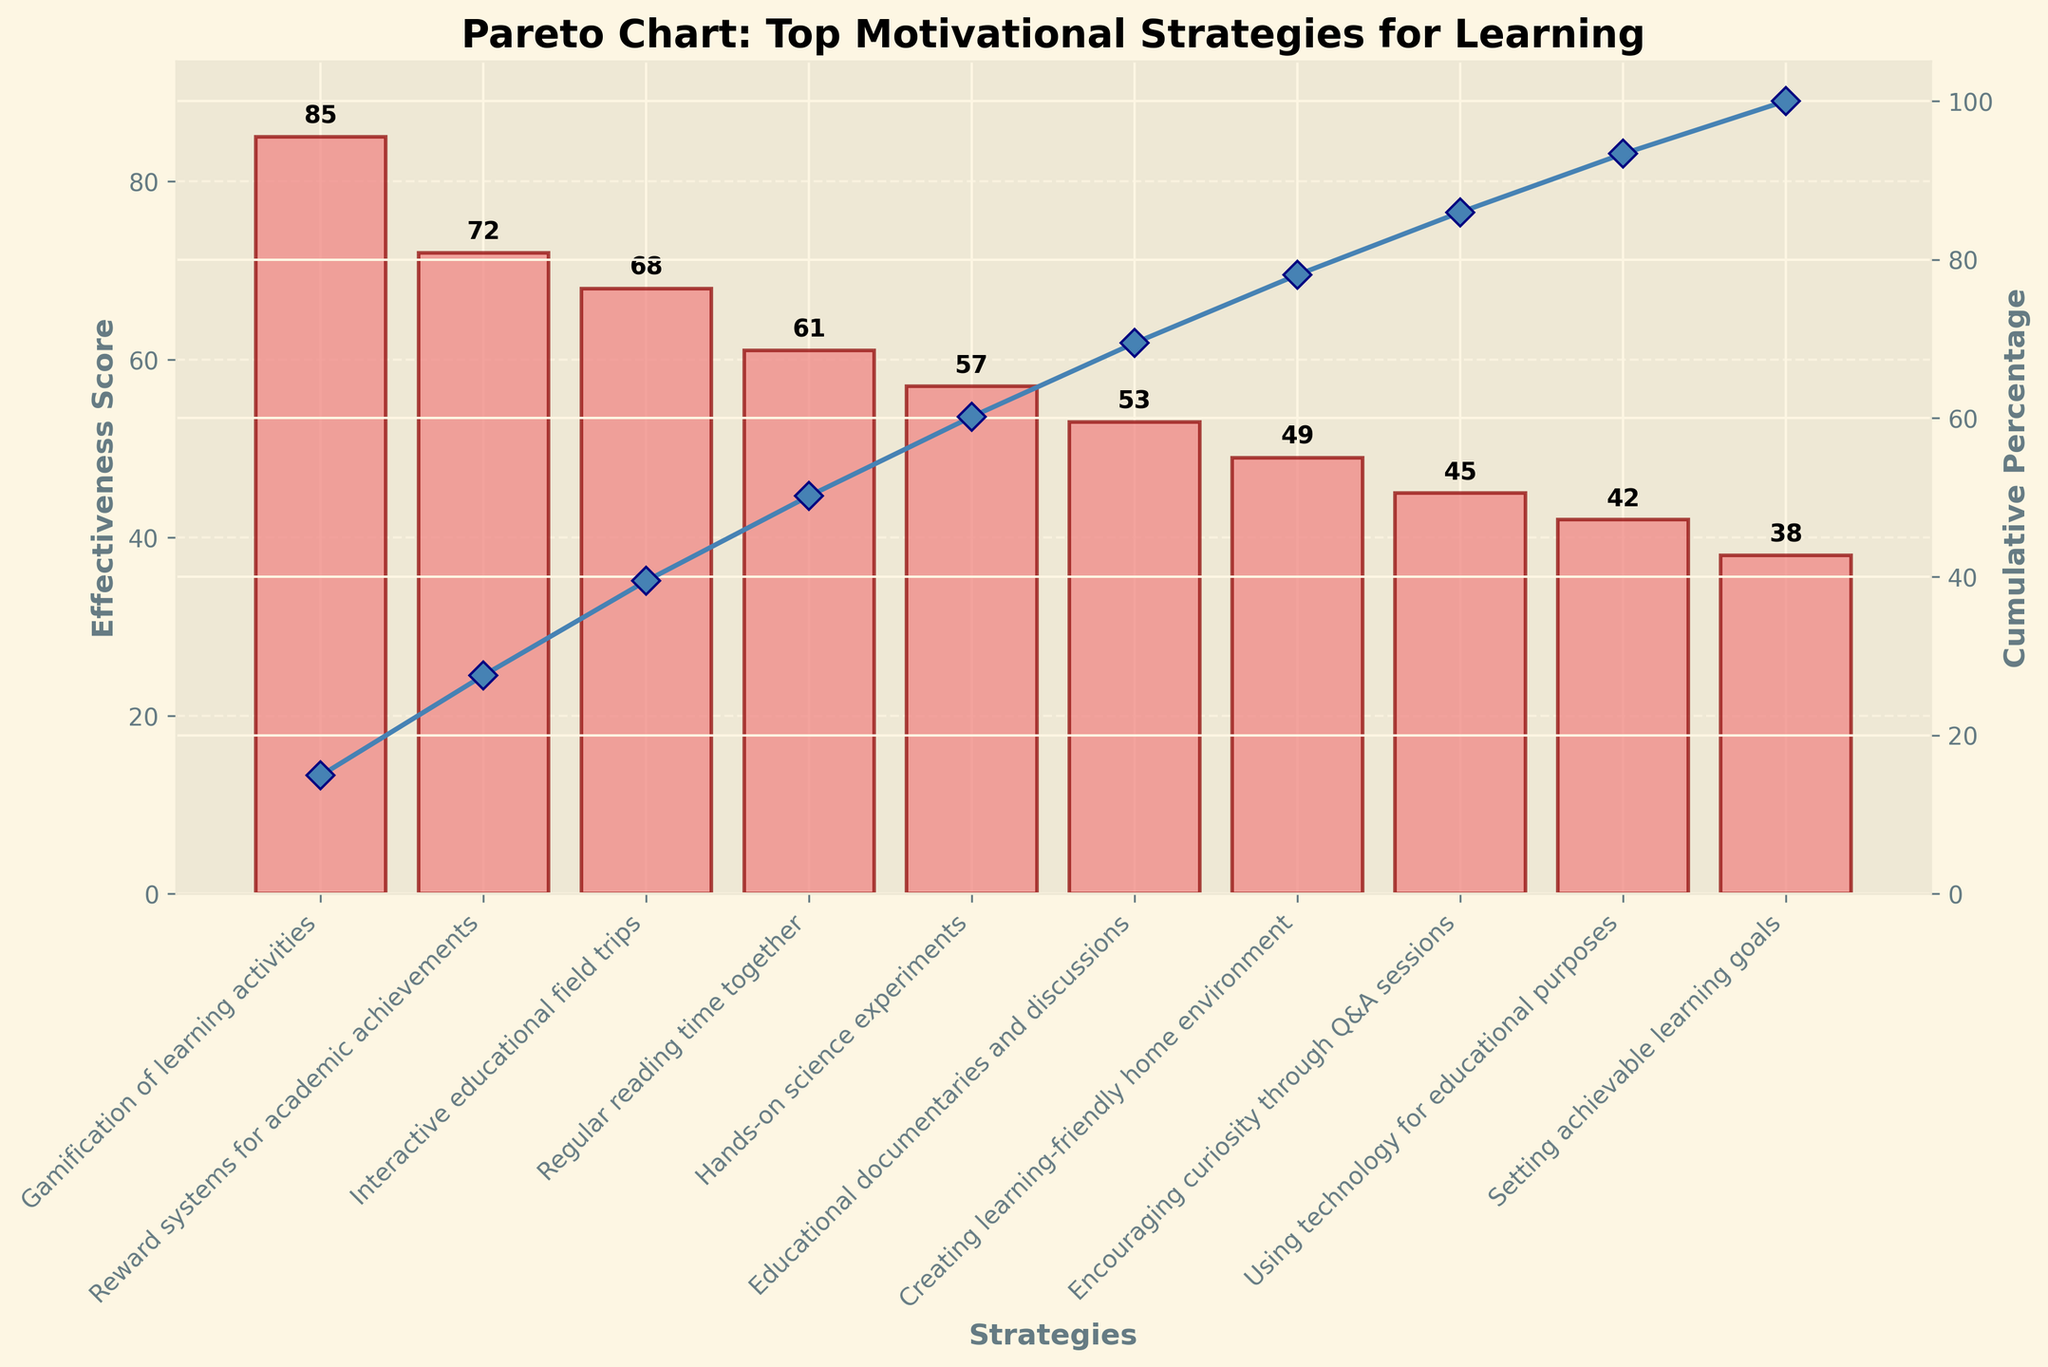What is the title of the Pareto chart? The title of a chart is usually displayed at the top. In this case, it reads, "Pareto Chart: Top Motivational Strategies for Learning".
Answer: Pareto Chart: Top Motivational Strategies for Learning Which motivational strategy has the highest effectiveness score? The highest bar represents the motivational strategy with the highest effectiveness score. In this chart, the tallest bar corresponds to "Gamification of learning activities" with a score of 85.
Answer: Gamification of learning activities What is the cumulative percentage for the top three strategies combined? To find the cumulative percentage, refer to the line plot and sum the cumulative percentages of the top three bars: 85 (Gamification of learning activities), 72 (Reward systems for academic achievements), and 68 (Interactive educational field trips). The respective cumulative percentages are approximately 31.8%, 58.8%, and 84.4%. So, the cumulative percentage for the top three strategies is about 84.4%.
Answer: 84.4% Which strategies are categorized as having a cumulative percentage below 50%? To determine this, look at the line plot and identify strategies before the cumulative percentage reaches 50%. The first two strategies "Gamification of learning activities" and "Reward systems for academic achievements" combined have a cumulative percentage of 58.8%, so they fall under this threshold.
Answer: Gamification of learning activities, Reward systems for academic achievements What is the cumulative percentage after including "Regular reading time together"? Sum the effectiveness scores of all strategies up to and including "Regular reading time together": 85 (Gamification of learning activities) + 72 (Reward systems for academic achievements) + 68 (Interactive educational field trips) + 61 (Regular reading time together) = 286. Cumulative percentage = (286 / Sum of all scores) * 100 = (286 / 510) * 100 ≈ 56.1%.
Answer: 56.1% What is the difference in effectiveness score between "Interactive educational field trips" and "Hands-on science experiments"? Subtract the effectiveness score of "Hands-on science experiments" from "Interactive educational field trips": 68 - 57 = 11.
Answer: 11 What is the average effectiveness score of all the strategies? Sum all the effectiveness scores and divide by the number of strategies: (85 + 72 + 68 + 61 + 57 + 53 + 49 + 45 + 42 + 38) / 10 = 510 / 10 = 51.
Answer: 51 Which strategy has the least effectiveness score and what is its value? The shortest bar represents the strategy with the least effectiveness score. "Setting achievable learning goals" has the lowest score of 38.
Answer: Setting achievable learning goals, 38 How many strategies have an effectiveness score greater than 50? Count the bars with scores above 50: "Gamification of learning activities" (85), "Reward systems for academic achievements" (72), "Interactive educational field trips" (68), "Regular reading time together" (61), "Hands-on science experiments" (57), and "Educational documentaries and discussions" (53). There are 6 such strategies.
Answer: 6 